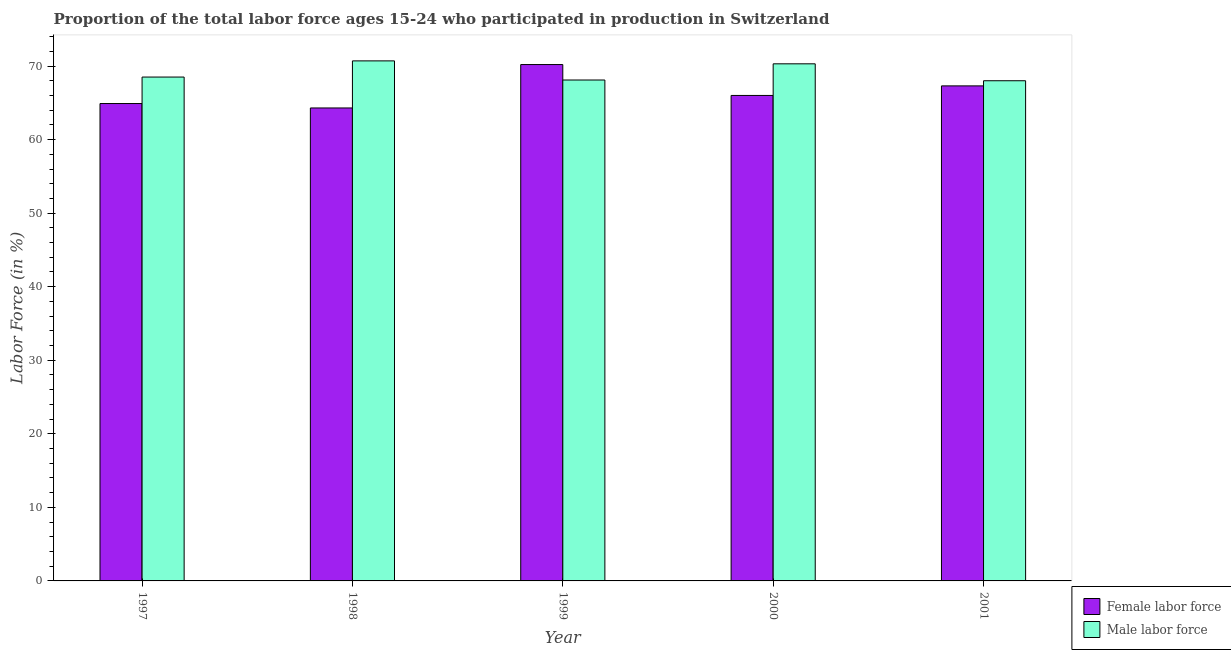Are the number of bars on each tick of the X-axis equal?
Provide a succinct answer. Yes. How many bars are there on the 3rd tick from the right?
Give a very brief answer. 2. What is the label of the 3rd group of bars from the left?
Your answer should be compact. 1999. In how many cases, is the number of bars for a given year not equal to the number of legend labels?
Provide a succinct answer. 0. What is the percentage of female labor force in 1997?
Offer a very short reply. 64.9. Across all years, what is the maximum percentage of male labour force?
Your response must be concise. 70.7. In which year was the percentage of male labour force minimum?
Keep it short and to the point. 2001. What is the total percentage of female labor force in the graph?
Make the answer very short. 332.7. What is the difference between the percentage of female labor force in 1998 and that in 1999?
Provide a short and direct response. -5.9. What is the difference between the percentage of male labour force in 2000 and the percentage of female labor force in 2001?
Ensure brevity in your answer.  2.3. What is the average percentage of male labour force per year?
Provide a succinct answer. 69.12. What is the ratio of the percentage of male labour force in 1997 to that in 2001?
Make the answer very short. 1.01. Is the difference between the percentage of male labour force in 1998 and 2000 greater than the difference between the percentage of female labor force in 1998 and 2000?
Your answer should be very brief. No. What is the difference between the highest and the second highest percentage of male labour force?
Offer a terse response. 0.4. What is the difference between the highest and the lowest percentage of female labor force?
Offer a very short reply. 5.9. In how many years, is the percentage of male labour force greater than the average percentage of male labour force taken over all years?
Your answer should be compact. 2. What does the 2nd bar from the left in 1998 represents?
Give a very brief answer. Male labor force. What does the 1st bar from the right in 2000 represents?
Your answer should be very brief. Male labor force. How many bars are there?
Provide a short and direct response. 10. Are all the bars in the graph horizontal?
Offer a very short reply. No. How many years are there in the graph?
Your answer should be compact. 5. Does the graph contain grids?
Offer a terse response. No. How many legend labels are there?
Ensure brevity in your answer.  2. What is the title of the graph?
Ensure brevity in your answer.  Proportion of the total labor force ages 15-24 who participated in production in Switzerland. What is the label or title of the X-axis?
Provide a short and direct response. Year. What is the label or title of the Y-axis?
Offer a very short reply. Labor Force (in %). What is the Labor Force (in %) of Female labor force in 1997?
Ensure brevity in your answer.  64.9. What is the Labor Force (in %) of Male labor force in 1997?
Your response must be concise. 68.5. What is the Labor Force (in %) in Female labor force in 1998?
Provide a short and direct response. 64.3. What is the Labor Force (in %) in Male labor force in 1998?
Your response must be concise. 70.7. What is the Labor Force (in %) of Female labor force in 1999?
Offer a very short reply. 70.2. What is the Labor Force (in %) of Male labor force in 1999?
Keep it short and to the point. 68.1. What is the Labor Force (in %) in Male labor force in 2000?
Offer a terse response. 70.3. What is the Labor Force (in %) of Female labor force in 2001?
Your answer should be compact. 67.3. Across all years, what is the maximum Labor Force (in %) of Female labor force?
Your response must be concise. 70.2. Across all years, what is the maximum Labor Force (in %) in Male labor force?
Provide a succinct answer. 70.7. Across all years, what is the minimum Labor Force (in %) in Female labor force?
Your answer should be very brief. 64.3. Across all years, what is the minimum Labor Force (in %) of Male labor force?
Provide a succinct answer. 68. What is the total Labor Force (in %) in Female labor force in the graph?
Keep it short and to the point. 332.7. What is the total Labor Force (in %) in Male labor force in the graph?
Your response must be concise. 345.6. What is the difference between the Labor Force (in %) in Female labor force in 1997 and that in 1998?
Offer a very short reply. 0.6. What is the difference between the Labor Force (in %) of Male labor force in 1997 and that in 2000?
Provide a short and direct response. -1.8. What is the difference between the Labor Force (in %) of Female labor force in 1998 and that in 1999?
Offer a very short reply. -5.9. What is the difference between the Labor Force (in %) in Male labor force in 1998 and that in 1999?
Provide a succinct answer. 2.6. What is the difference between the Labor Force (in %) in Female labor force in 1998 and that in 2001?
Provide a succinct answer. -3. What is the difference between the Labor Force (in %) of Male labor force in 1998 and that in 2001?
Your answer should be very brief. 2.7. What is the difference between the Labor Force (in %) in Female labor force in 1999 and that in 2001?
Keep it short and to the point. 2.9. What is the difference between the Labor Force (in %) in Male labor force in 1999 and that in 2001?
Your answer should be compact. 0.1. What is the difference between the Labor Force (in %) in Female labor force in 1997 and the Labor Force (in %) in Male labor force in 1998?
Provide a short and direct response. -5.8. What is the difference between the Labor Force (in %) of Female labor force in 1997 and the Labor Force (in %) of Male labor force in 2000?
Offer a very short reply. -5.4. What is the difference between the Labor Force (in %) of Female labor force in 1997 and the Labor Force (in %) of Male labor force in 2001?
Offer a very short reply. -3.1. What is the difference between the Labor Force (in %) of Female labor force in 2000 and the Labor Force (in %) of Male labor force in 2001?
Make the answer very short. -2. What is the average Labor Force (in %) of Female labor force per year?
Offer a terse response. 66.54. What is the average Labor Force (in %) of Male labor force per year?
Make the answer very short. 69.12. In the year 1997, what is the difference between the Labor Force (in %) of Female labor force and Labor Force (in %) of Male labor force?
Your response must be concise. -3.6. In the year 1998, what is the difference between the Labor Force (in %) in Female labor force and Labor Force (in %) in Male labor force?
Your response must be concise. -6.4. In the year 1999, what is the difference between the Labor Force (in %) of Female labor force and Labor Force (in %) of Male labor force?
Offer a terse response. 2.1. In the year 2000, what is the difference between the Labor Force (in %) in Female labor force and Labor Force (in %) in Male labor force?
Ensure brevity in your answer.  -4.3. What is the ratio of the Labor Force (in %) of Female labor force in 1997 to that in 1998?
Offer a very short reply. 1.01. What is the ratio of the Labor Force (in %) of Male labor force in 1997 to that in 1998?
Provide a succinct answer. 0.97. What is the ratio of the Labor Force (in %) in Female labor force in 1997 to that in 1999?
Provide a short and direct response. 0.92. What is the ratio of the Labor Force (in %) in Male labor force in 1997 to that in 1999?
Your answer should be compact. 1.01. What is the ratio of the Labor Force (in %) of Female labor force in 1997 to that in 2000?
Offer a very short reply. 0.98. What is the ratio of the Labor Force (in %) in Male labor force in 1997 to that in 2000?
Your answer should be compact. 0.97. What is the ratio of the Labor Force (in %) of Female labor force in 1997 to that in 2001?
Your answer should be compact. 0.96. What is the ratio of the Labor Force (in %) in Male labor force in 1997 to that in 2001?
Give a very brief answer. 1.01. What is the ratio of the Labor Force (in %) in Female labor force in 1998 to that in 1999?
Provide a succinct answer. 0.92. What is the ratio of the Labor Force (in %) in Male labor force in 1998 to that in 1999?
Provide a short and direct response. 1.04. What is the ratio of the Labor Force (in %) of Female labor force in 1998 to that in 2000?
Your response must be concise. 0.97. What is the ratio of the Labor Force (in %) of Female labor force in 1998 to that in 2001?
Ensure brevity in your answer.  0.96. What is the ratio of the Labor Force (in %) in Male labor force in 1998 to that in 2001?
Ensure brevity in your answer.  1.04. What is the ratio of the Labor Force (in %) of Female labor force in 1999 to that in 2000?
Provide a short and direct response. 1.06. What is the ratio of the Labor Force (in %) of Male labor force in 1999 to that in 2000?
Your answer should be very brief. 0.97. What is the ratio of the Labor Force (in %) in Female labor force in 1999 to that in 2001?
Your answer should be compact. 1.04. What is the ratio of the Labor Force (in %) in Male labor force in 1999 to that in 2001?
Your answer should be very brief. 1. What is the ratio of the Labor Force (in %) of Female labor force in 2000 to that in 2001?
Offer a terse response. 0.98. What is the ratio of the Labor Force (in %) in Male labor force in 2000 to that in 2001?
Give a very brief answer. 1.03. What is the difference between the highest and the second highest Labor Force (in %) of Female labor force?
Give a very brief answer. 2.9. What is the difference between the highest and the lowest Labor Force (in %) in Female labor force?
Provide a short and direct response. 5.9. 